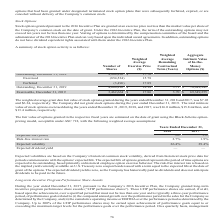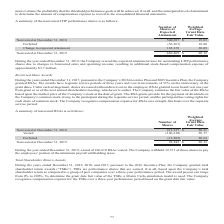According to Aci Worldwide's financial document, What was the additional stock-based compensation expense in 2019? According to the financial document, $3.7 million (in millions). The relevant text states: "stock-based compensation expense of approximately $3.7 million. Restricted Share Awards..." Also, What was the number of nonvested shares at expected attainment in 2019? According to the financial document, 669,469. The relevant text states: "Nonvested at December 31, 2019 669,469 $ 20.12..." Also, What was the number of nonvested shares at expected attainment in 2018? According to the financial document, 540,697. The relevant text states: "Nonvested at December 31, 2018 540,697 $ 19.83..." Also, can you calculate: What was the change in nonvested shares at expected attainment between 2018 and 2019? Based on the calculation: 669,469-540,697, the result is 128772. This is based on the information: "Nonvested at December 31, 2019 669,469 $ 20.12 Nonvested at December 31, 2018 540,697 $ 19.83..." The key data points involved are: 540,697, 669,469. Also, can you calculate: What was the percentage change in nonvested shares at expected attainment between 2018 and 2019? To answer this question, I need to perform calculations using the financial data. The calculation is: (669,469-540,697)/540,697, which equals 23.82 (percentage). This is based on the information: "Nonvested at December 31, 2019 669,469 $ 20.12 Nonvested at December 31, 2018 540,697 $ 19.83..." The key data points involved are: 540,697, 669,469. Also, can you calculate: What is the difference in Weighted Average Grant Date Fair Value between nonvested shares and forfeited shares in 2018? Based on the calculation: $19.83-18.80, the result is 1.03. This is based on the information: "Forfeited (56,567 ) 18.80 Nonvested at December 31, 2018 540,697 $ 19.83..." The key data points involved are: 18.80, 19.83. 